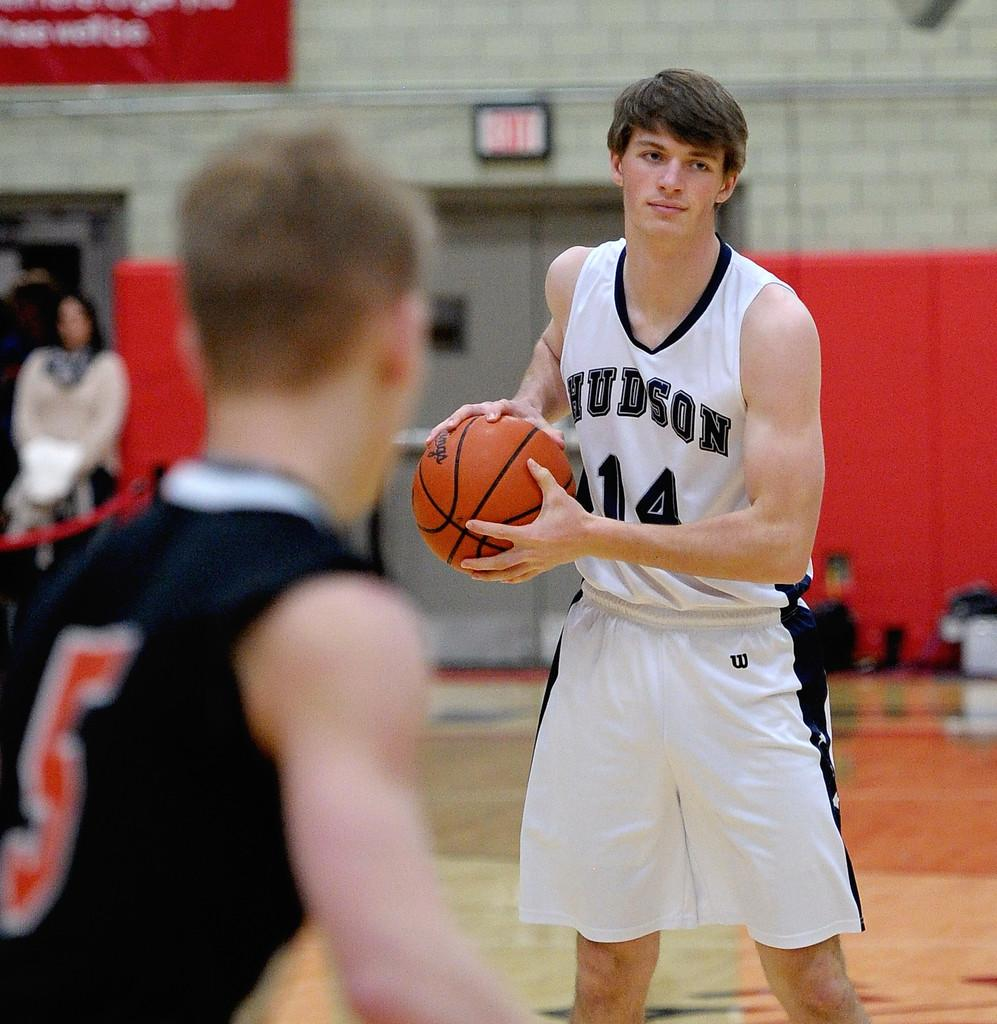Provide a one-sentence caption for the provided image. The player for Hudson with the number 14 on his jersey has the ball. 